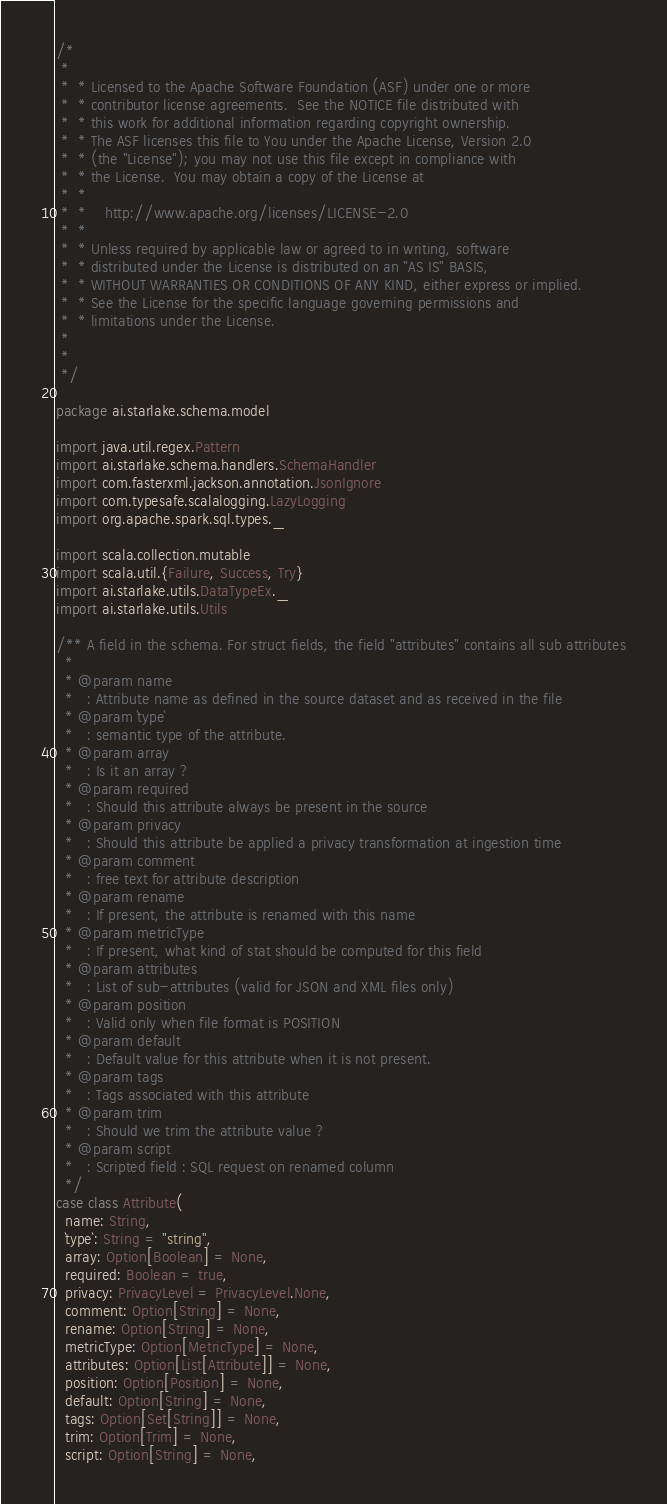Convert code to text. <code><loc_0><loc_0><loc_500><loc_500><_Scala_>/*
 *
 *  * Licensed to the Apache Software Foundation (ASF) under one or more
 *  * contributor license agreements.  See the NOTICE file distributed with
 *  * this work for additional information regarding copyright ownership.
 *  * The ASF licenses this file to You under the Apache License, Version 2.0
 *  * (the "License"); you may not use this file except in compliance with
 *  * the License.  You may obtain a copy of the License at
 *  *
 *  *    http://www.apache.org/licenses/LICENSE-2.0
 *  *
 *  * Unless required by applicable law or agreed to in writing, software
 *  * distributed under the License is distributed on an "AS IS" BASIS,
 *  * WITHOUT WARRANTIES OR CONDITIONS OF ANY KIND, either express or implied.
 *  * See the License for the specific language governing permissions and
 *  * limitations under the License.
 *
 *
 */

package ai.starlake.schema.model

import java.util.regex.Pattern
import ai.starlake.schema.handlers.SchemaHandler
import com.fasterxml.jackson.annotation.JsonIgnore
import com.typesafe.scalalogging.LazyLogging
import org.apache.spark.sql.types._

import scala.collection.mutable
import scala.util.{Failure, Success, Try}
import ai.starlake.utils.DataTypeEx._
import ai.starlake.utils.Utils

/** A field in the schema. For struct fields, the field "attributes" contains all sub attributes
  *
  * @param name
  *   : Attribute name as defined in the source dataset and as received in the file
  * @param `type`
  *   : semantic type of the attribute.
  * @param array
  *   : Is it an array ?
  * @param required
  *   : Should this attribute always be present in the source
  * @param privacy
  *   : Should this attribute be applied a privacy transformation at ingestion time
  * @param comment
  *   : free text for attribute description
  * @param rename
  *   : If present, the attribute is renamed with this name
  * @param metricType
  *   : If present, what kind of stat should be computed for this field
  * @param attributes
  *   : List of sub-attributes (valid for JSON and XML files only)
  * @param position
  *   : Valid only when file format is POSITION
  * @param default
  *   : Default value for this attribute when it is not present.
  * @param tags
  *   : Tags associated with this attribute
  * @param trim
  *   : Should we trim the attribute value ?
  * @param script
  *   : Scripted field : SQL request on renamed column
  */
case class Attribute(
  name: String,
  `type`: String = "string",
  array: Option[Boolean] = None,
  required: Boolean = true,
  privacy: PrivacyLevel = PrivacyLevel.None,
  comment: Option[String] = None,
  rename: Option[String] = None,
  metricType: Option[MetricType] = None,
  attributes: Option[List[Attribute]] = None,
  position: Option[Position] = None,
  default: Option[String] = None,
  tags: Option[Set[String]] = None,
  trim: Option[Trim] = None,
  script: Option[String] = None,</code> 